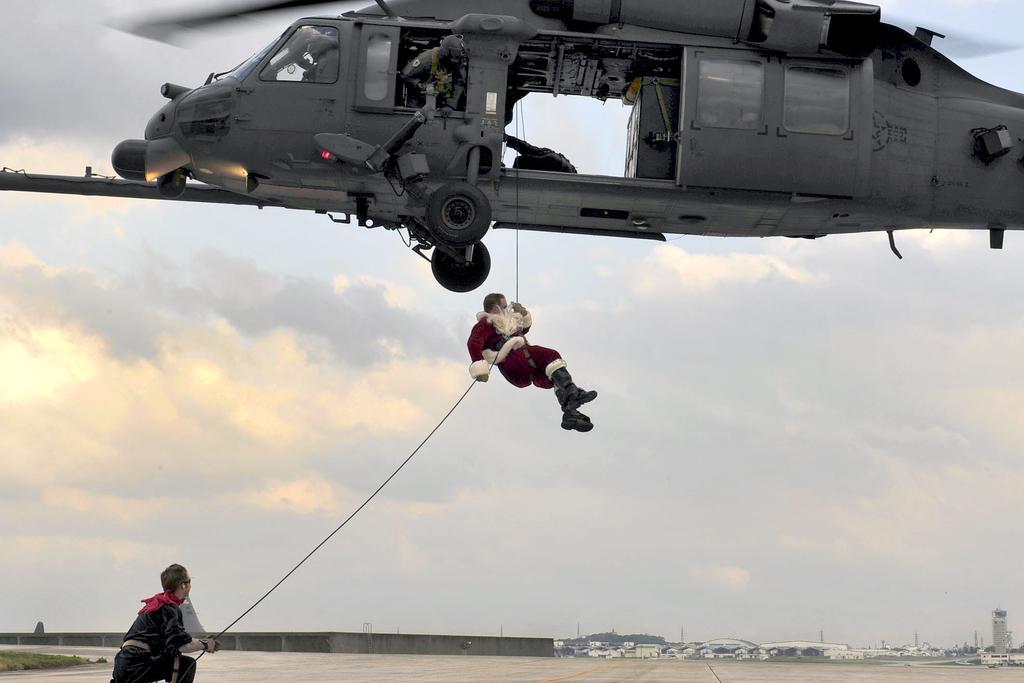In one or two sentences, can you explain what this image depicts? In this image, there is an outside view. There is a helicopter at top of the image. There is a person in the middle of the image hanging on rope which is attached to the helicopter. There is a person in the bottom left of the image holding a rope with his hand. 